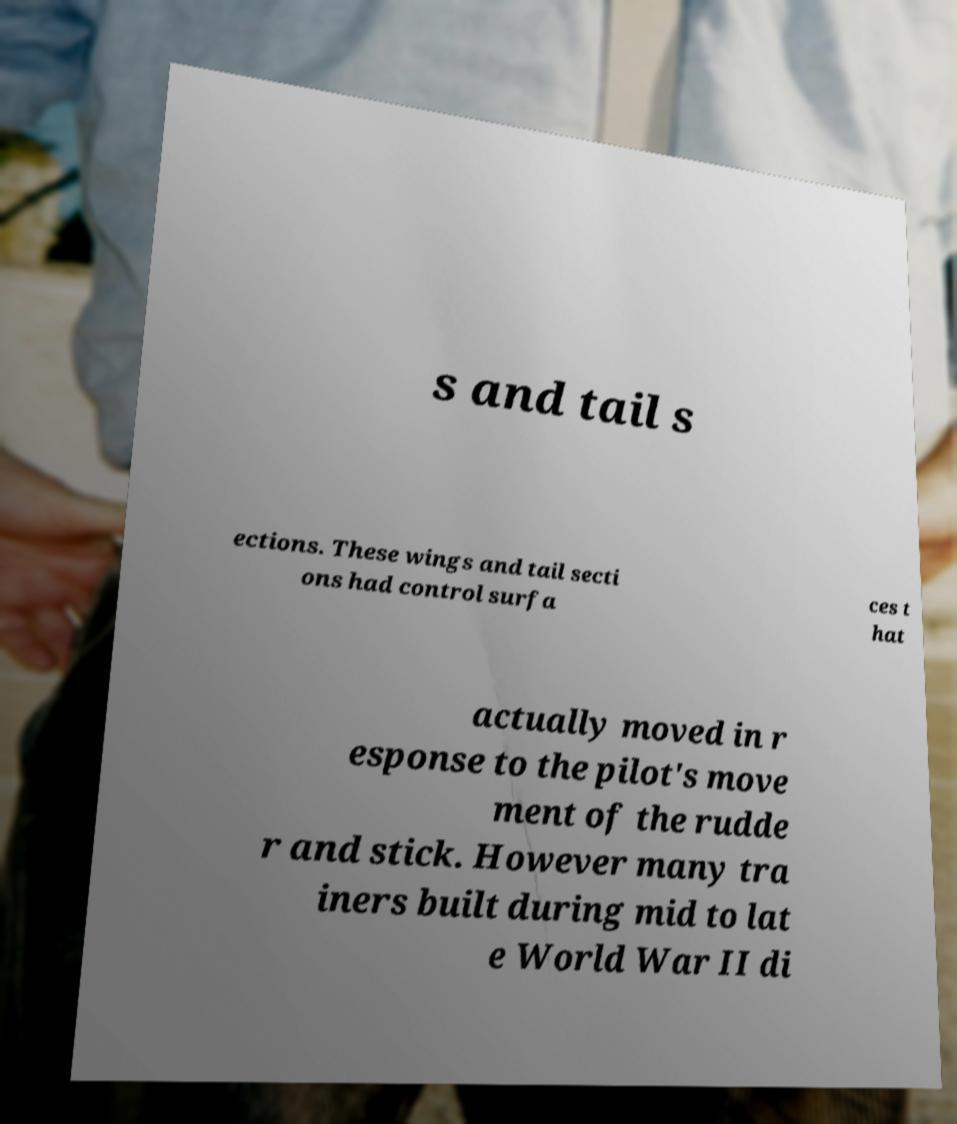For documentation purposes, I need the text within this image transcribed. Could you provide that? s and tail s ections. These wings and tail secti ons had control surfa ces t hat actually moved in r esponse to the pilot's move ment of the rudde r and stick. However many tra iners built during mid to lat e World War II di 